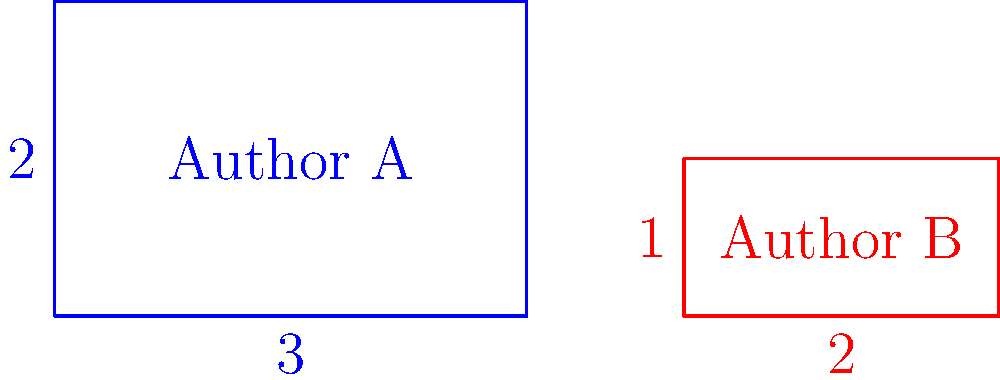In the diagram above, rectangles represent book sales for two authors you represent. The area of each rectangle corresponds to the total number of books sold. If the rectangles are congruent, what is the ratio of the width of Author A's rectangle to the width of Author B's rectangle? To solve this problem, let's follow these steps:

1) For rectangles to be congruent, they must have the same area and shape.

2) We're given the dimensions of both rectangles:
   Author A: 3 units wide, 2 units tall
   Author B: 2 units wide, 1 unit tall

3) Let's calculate the areas:
   Author A: $3 \times 2 = 6$ square units
   Author B: $2 \times 1 = 2$ square units

4) The areas are not equal, so the rectangles are not congruent as they are.

5) For them to be congruent, we need to assume that the scale is different for each rectangle.

6) If they are congruent, their aspect ratios must be the same:
   Author A: $\frac{width}{height} = \frac{3}{2}$
   Author B: $\frac{width}{height} = \frac{2}{1} = 2$

7) These ratios are indeed the same: $\frac{3}{2} = \frac{6}{4} = \frac{2}{1}$

8) Now, to find the ratio of their widths:
   $\frac{width_A}{width_B} = \frac{3}{2} = 1.5$

Therefore, the ratio of the width of Author A's rectangle to the width of Author B's rectangle is 3:2 or 1.5:1.
Answer: $\frac{3}{2}$ or 1.5:1 